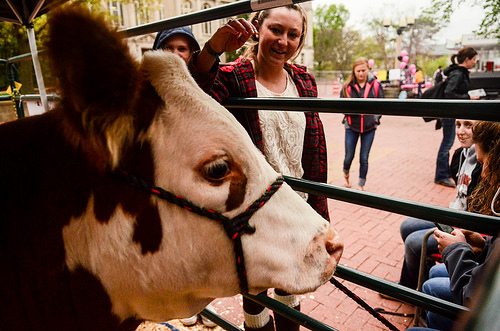<image>
Can you confirm if the person is to the right of the cow? No. The person is not to the right of the cow. The horizontal positioning shows a different relationship. 